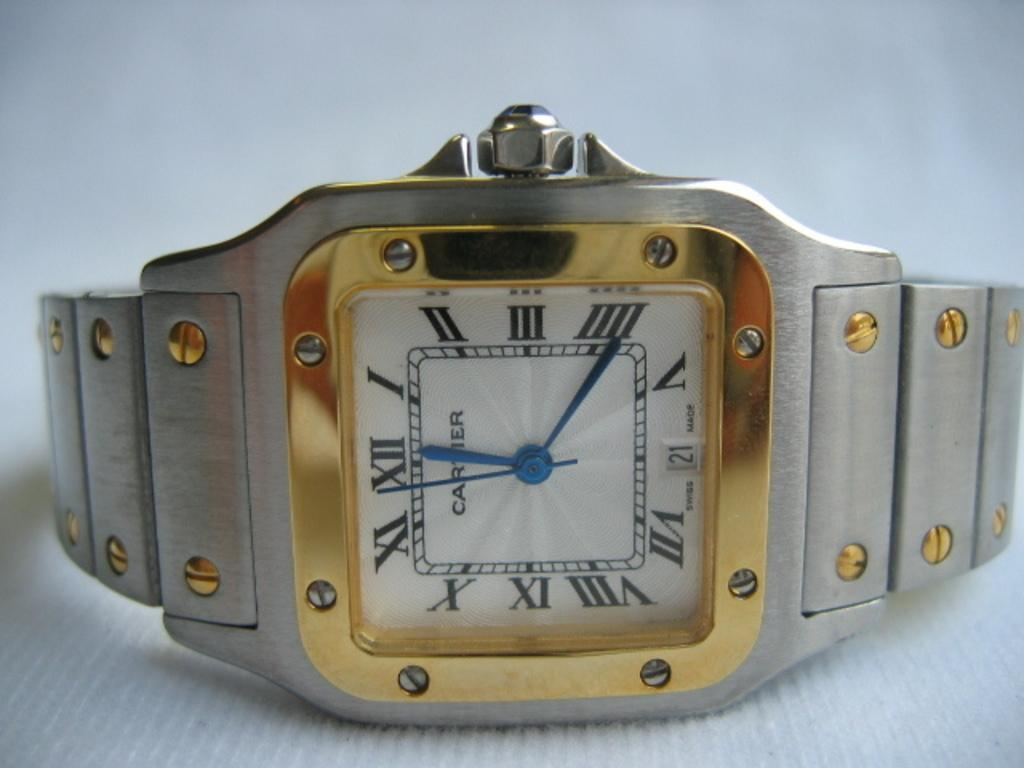<image>
Present a compact description of the photo's key features. a Cartier watch with a silver band and gold trim. 